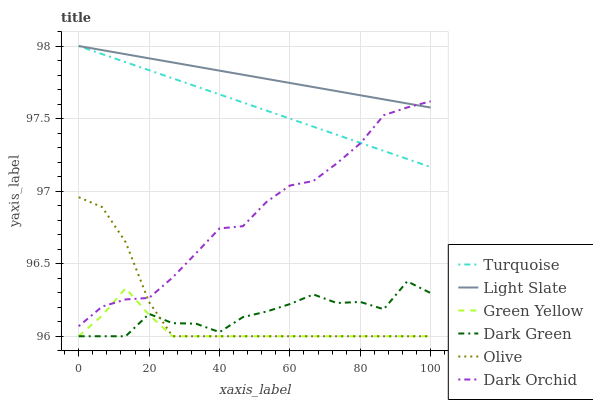Does Green Yellow have the minimum area under the curve?
Answer yes or no. Yes. Does Light Slate have the maximum area under the curve?
Answer yes or no. Yes. Does Dark Orchid have the minimum area under the curve?
Answer yes or no. No. Does Dark Orchid have the maximum area under the curve?
Answer yes or no. No. Is Light Slate the smoothest?
Answer yes or no. Yes. Is Dark Green the roughest?
Answer yes or no. Yes. Is Dark Orchid the smoothest?
Answer yes or no. No. Is Dark Orchid the roughest?
Answer yes or no. No. Does Olive have the lowest value?
Answer yes or no. Yes. Does Dark Orchid have the lowest value?
Answer yes or no. No. Does Light Slate have the highest value?
Answer yes or no. Yes. Does Dark Orchid have the highest value?
Answer yes or no. No. Is Dark Green less than Dark Orchid?
Answer yes or no. Yes. Is Turquoise greater than Green Yellow?
Answer yes or no. Yes. Does Dark Orchid intersect Olive?
Answer yes or no. Yes. Is Dark Orchid less than Olive?
Answer yes or no. No. Is Dark Orchid greater than Olive?
Answer yes or no. No. Does Dark Green intersect Dark Orchid?
Answer yes or no. No. 